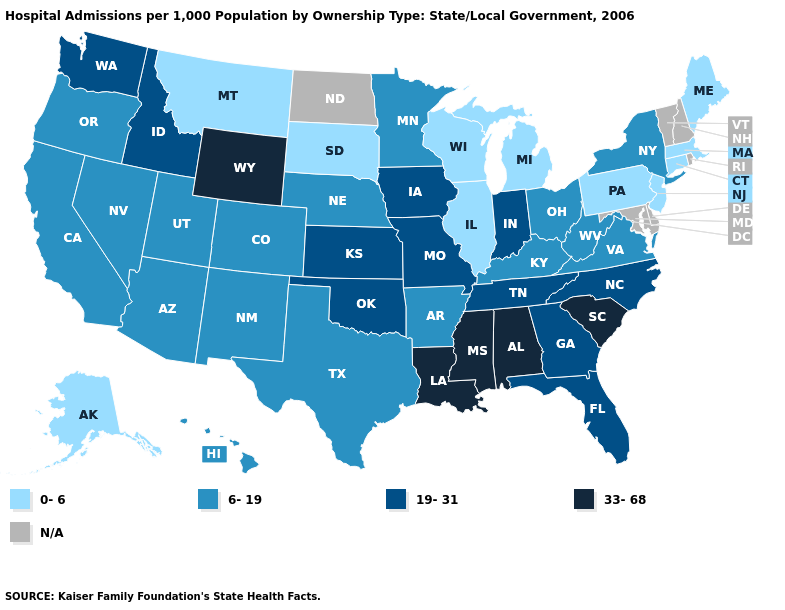Which states have the lowest value in the South?
Write a very short answer. Arkansas, Kentucky, Texas, Virginia, West Virginia. Among the states that border Nevada , does Idaho have the highest value?
Quick response, please. Yes. What is the highest value in the USA?
Keep it brief. 33-68. Name the states that have a value in the range 19-31?
Keep it brief. Florida, Georgia, Idaho, Indiana, Iowa, Kansas, Missouri, North Carolina, Oklahoma, Tennessee, Washington. Name the states that have a value in the range 0-6?
Be succinct. Alaska, Connecticut, Illinois, Maine, Massachusetts, Michigan, Montana, New Jersey, Pennsylvania, South Dakota, Wisconsin. What is the lowest value in the USA?
Concise answer only. 0-6. Does the map have missing data?
Short answer required. Yes. Which states have the highest value in the USA?
Be succinct. Alabama, Louisiana, Mississippi, South Carolina, Wyoming. Does the map have missing data?
Keep it brief. Yes. Which states have the lowest value in the USA?
Short answer required. Alaska, Connecticut, Illinois, Maine, Massachusetts, Michigan, Montana, New Jersey, Pennsylvania, South Dakota, Wisconsin. Which states have the highest value in the USA?
Quick response, please. Alabama, Louisiana, Mississippi, South Carolina, Wyoming. What is the value of California?
Concise answer only. 6-19. Does Connecticut have the lowest value in the USA?
Write a very short answer. Yes. How many symbols are there in the legend?
Concise answer only. 5. What is the highest value in states that border Virginia?
Short answer required. 19-31. 